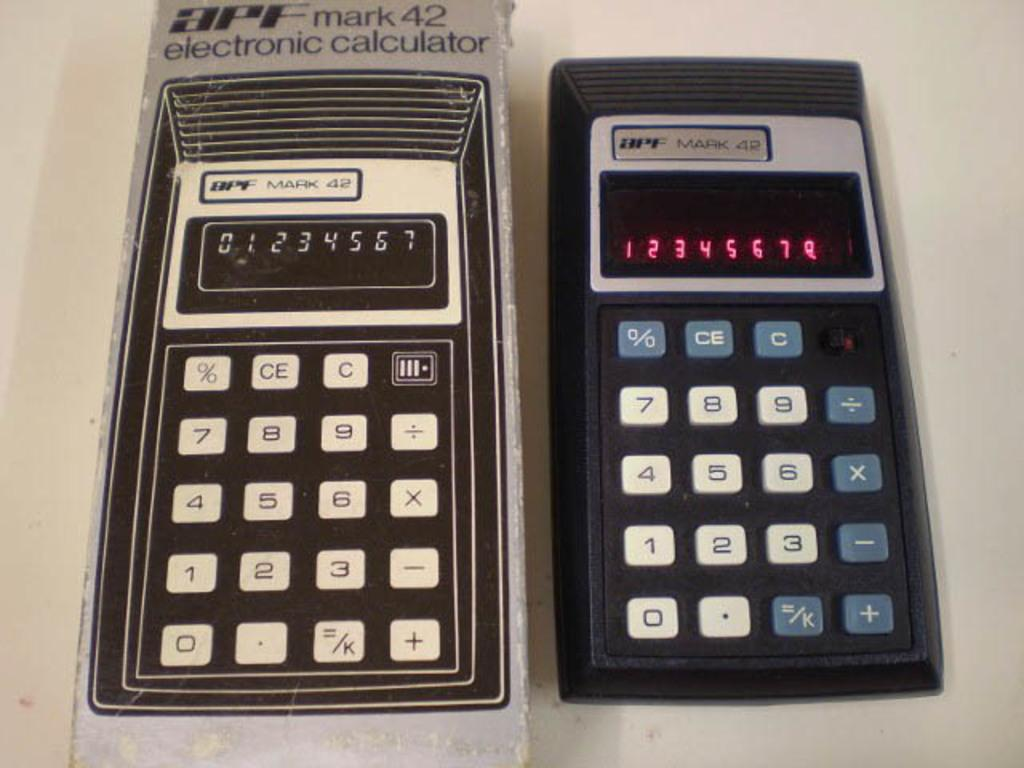Provide a one-sentence caption for the provided image. APF mark 42 electronic calculator displayed next to it's original packaging. 